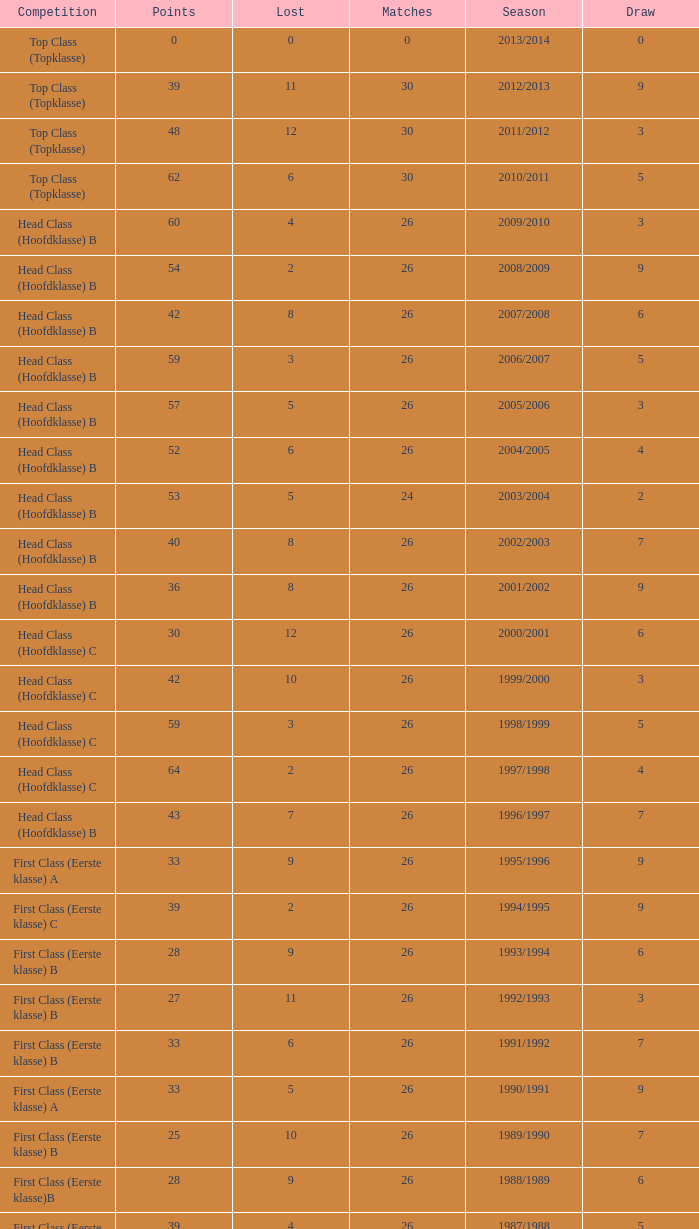What is the total number of matches with a loss less than 5 in the 2008/2009 season and has a draw larger than 9? 0.0. 